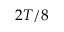<formula> <loc_0><loc_0><loc_500><loc_500>2 T / 8</formula> 